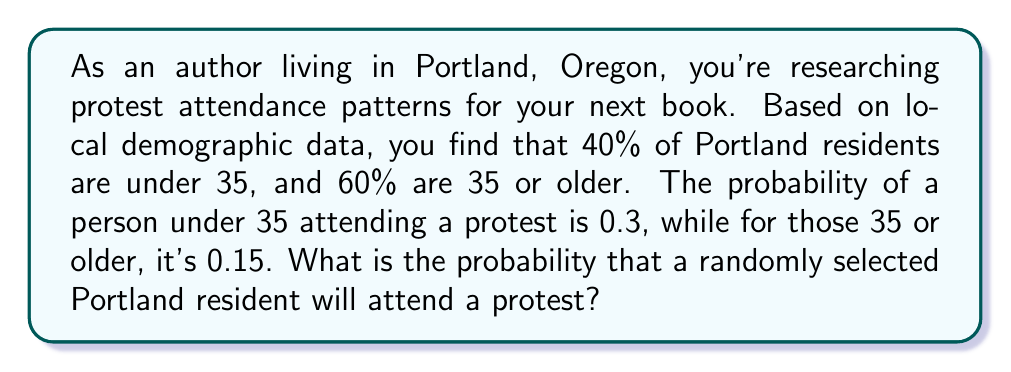Can you solve this math problem? Let's approach this step-by-step using the law of total probability:

1) Define events:
   A: Person attends a protest
   U: Person is under 35
   O: Person is 35 or older

2) Given probabilities:
   $P(U) = 0.4$
   $P(O) = 0.6$
   $P(A|U) = 0.3$
   $P(A|O) = 0.15$

3) Law of Total Probability:
   $P(A) = P(A|U) \cdot P(U) + P(A|O) \cdot P(O)$

4) Substitute the values:
   $P(A) = 0.3 \cdot 0.4 + 0.15 \cdot 0.6$

5) Calculate:
   $P(A) = 0.12 + 0.09 = 0.21$

Therefore, the probability that a randomly selected Portland resident will attend a protest is 0.21 or 21%.
Answer: 0.21 